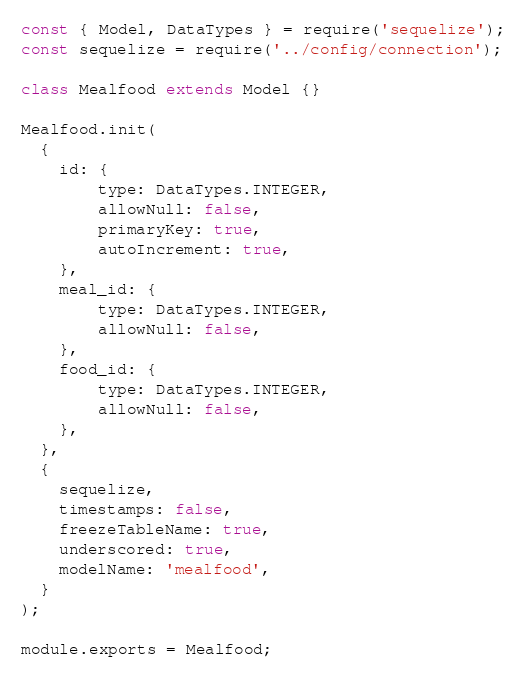<code> <loc_0><loc_0><loc_500><loc_500><_JavaScript_>const { Model, DataTypes } = require('sequelize');
const sequelize = require('../config/connection');

class Mealfood extends Model {}

Mealfood.init(
  {
    id: {
        type: DataTypes.INTEGER,
        allowNull: false,
        primaryKey: true,
        autoIncrement: true,
    },
    meal_id: {
        type: DataTypes.INTEGER,
        allowNull: false,
    },
    food_id: {
        type: DataTypes.INTEGER,
        allowNull: false,
    },
  },
  {
    sequelize,
    timestamps: false,
    freezeTableName: true,
    underscored: true,
    modelName: 'mealfood',
  }
);

module.exports = Mealfood;
</code> 